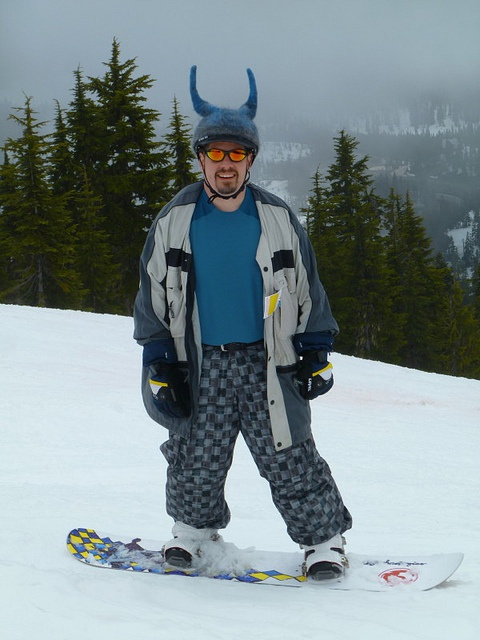Describe the objects in this image and their specific colors. I can see people in darkgray, black, blue, and gray tones and snowboard in darkgray, lightgray, and lightblue tones in this image. 